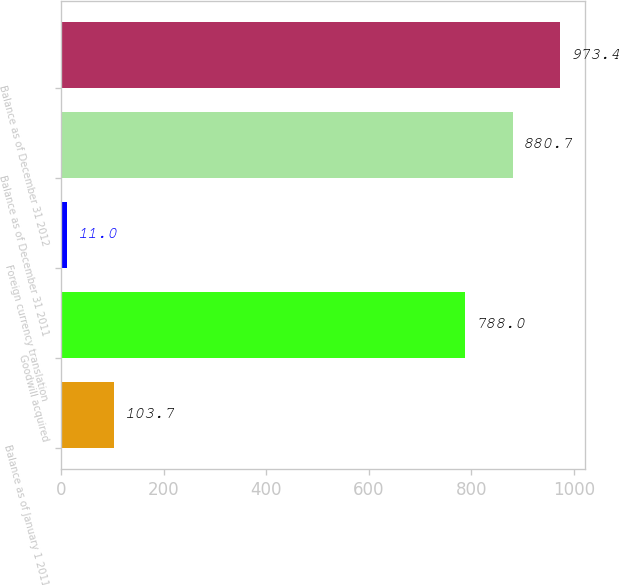<chart> <loc_0><loc_0><loc_500><loc_500><bar_chart><fcel>Balance as of January 1 2011<fcel>Goodwill acquired<fcel>Foreign currency translation<fcel>Balance as of December 31 2011<fcel>Balance as of December 31 2012<nl><fcel>103.7<fcel>788<fcel>11<fcel>880.7<fcel>973.4<nl></chart> 